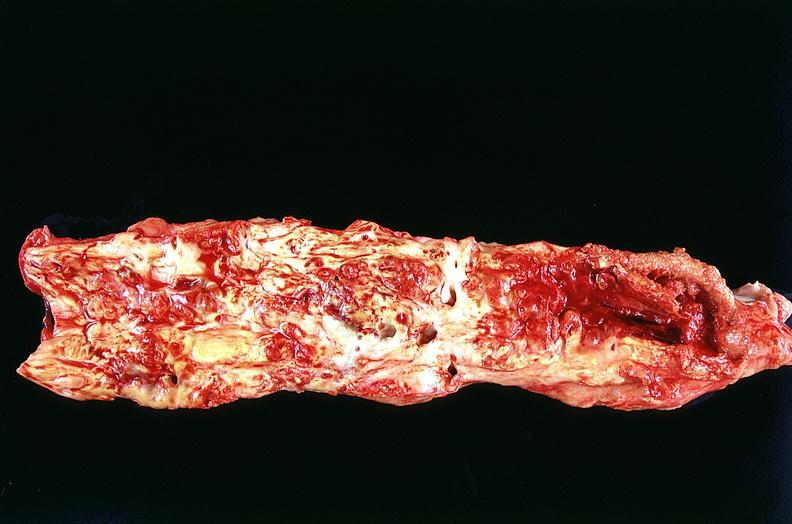does artery show aorta, abdominal?
Answer the question using a single word or phrase. No 